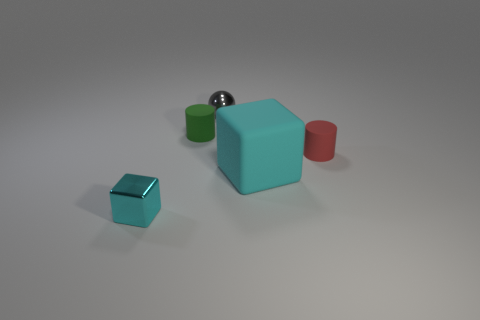Are there any brown metal cubes? no 